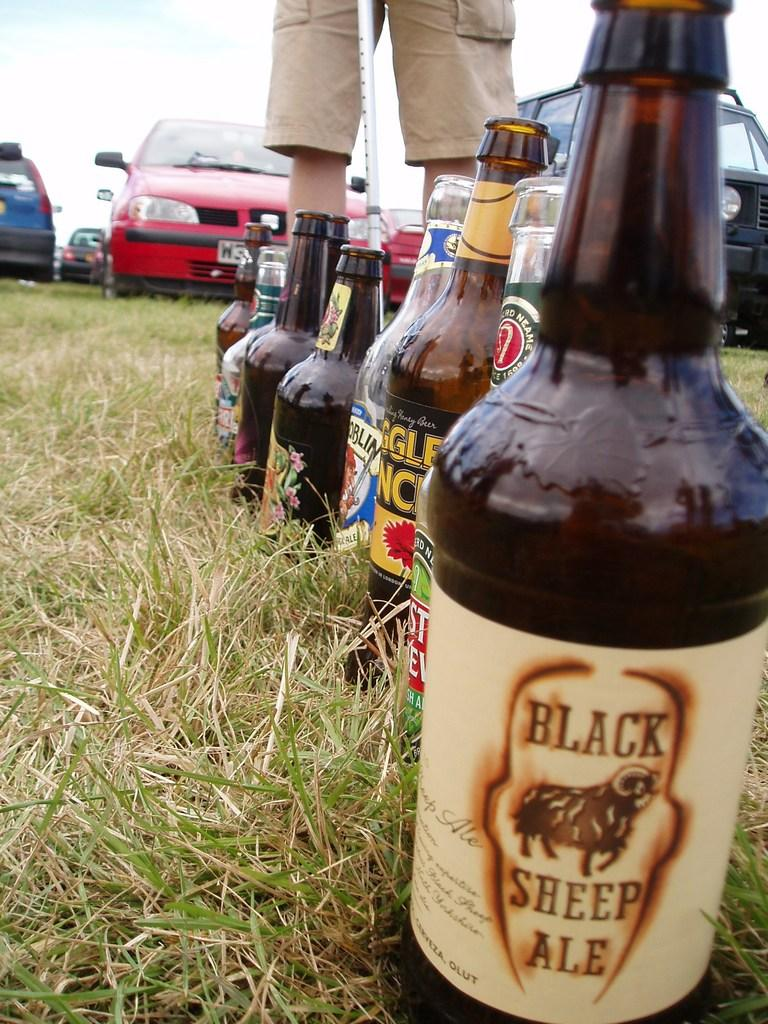What objects are placed in a line on the grass in the image? There are bottles placed in a line on the grass. What is the person standing with in the image? The person is standing with a stick. What can be seen in the background of the image? Cars and the sky are visible in the background. What is the value of the exchange between the person and the wrist in the image? There is no exchange or wrist present in the image. What type of wrist is the person wearing in the image? There is no wrist or wrist accessory mentioned or visible in the image. 